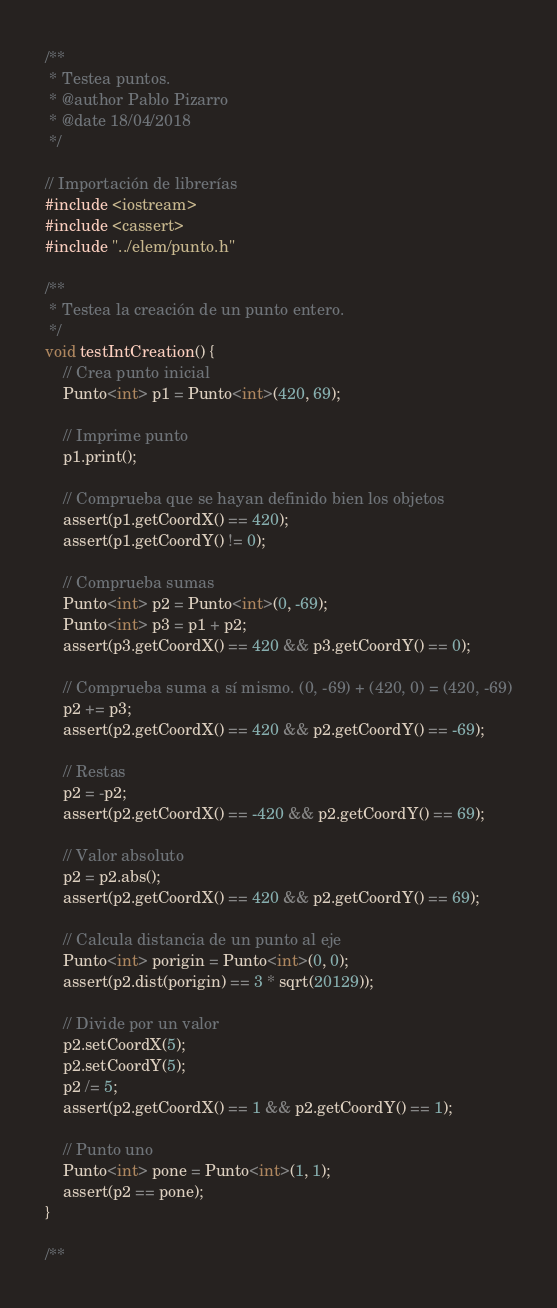Convert code to text. <code><loc_0><loc_0><loc_500><loc_500><_C++_>/**
 * Testea puntos.
 * @author Pablo Pizarro
 * @date 18/04/2018
 */

// Importación de librerías
#include <iostream>
#include <cassert>
#include "../elem/punto.h"

/**
 * Testea la creación de un punto entero.
 */
void testIntCreation() {
    // Crea punto inicial
    Punto<int> p1 = Punto<int>(420, 69);

    // Imprime punto
    p1.print();

    // Comprueba que se hayan definido bien los objetos
    assert(p1.getCoordX() == 420);
    assert(p1.getCoordY() != 0);

    // Comprueba sumas
    Punto<int> p2 = Punto<int>(0, -69);
    Punto<int> p3 = p1 + p2;
    assert(p3.getCoordX() == 420 && p3.getCoordY() == 0);

    // Comprueba suma a sí mismo. (0, -69) + (420, 0) = (420, -69)
    p2 += p3;
    assert(p2.getCoordX() == 420 && p2.getCoordY() == -69);

    // Restas
    p2 = -p2;
    assert(p2.getCoordX() == -420 && p2.getCoordY() == 69);

    // Valor absoluto
    p2 = p2.abs();
    assert(p2.getCoordX() == 420 && p2.getCoordY() == 69);

    // Calcula distancia de un punto al eje
    Punto<int> porigin = Punto<int>(0, 0);
    assert(p2.dist(porigin) == 3 * sqrt(20129));

    // Divide por un valor
    p2.setCoordX(5);
    p2.setCoordY(5);
    p2 /= 5;
    assert(p2.getCoordX() == 1 && p2.getCoordY() == 1);

    // Punto uno
    Punto<int> pone = Punto<int>(1, 1);
    assert(p2 == pone);
}

/**</code> 